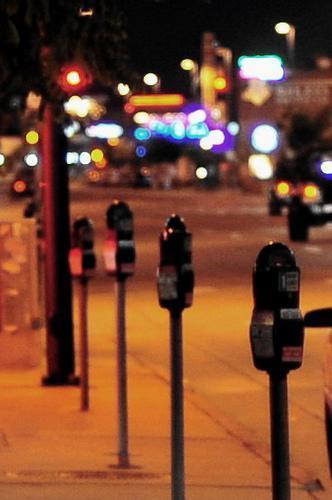How many parking meters are there?
Give a very brief answer. 3. How many chairs are in this shot?
Give a very brief answer. 0. 